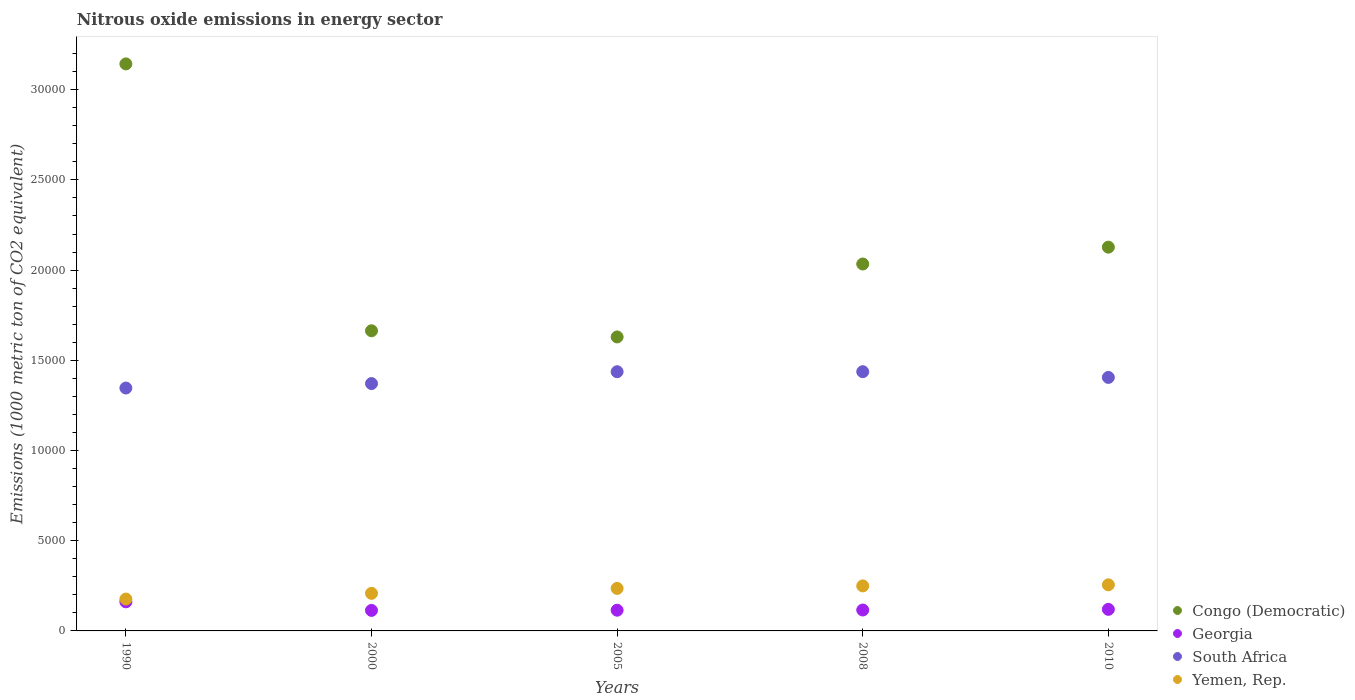How many different coloured dotlines are there?
Give a very brief answer. 4. Is the number of dotlines equal to the number of legend labels?
Ensure brevity in your answer.  Yes. What is the amount of nitrous oxide emitted in Georgia in 2010?
Keep it short and to the point. 1195.6. Across all years, what is the maximum amount of nitrous oxide emitted in Yemen, Rep.?
Offer a very short reply. 2555.7. Across all years, what is the minimum amount of nitrous oxide emitted in Yemen, Rep.?
Your answer should be compact. 1766.7. What is the total amount of nitrous oxide emitted in Yemen, Rep. in the graph?
Provide a short and direct response. 1.13e+04. What is the difference between the amount of nitrous oxide emitted in Congo (Democratic) in 1990 and that in 2000?
Provide a succinct answer. 1.48e+04. What is the difference between the amount of nitrous oxide emitted in South Africa in 2005 and the amount of nitrous oxide emitted in Congo (Democratic) in 2008?
Your answer should be very brief. -5970.6. What is the average amount of nitrous oxide emitted in Yemen, Rep. per year?
Provide a short and direct response. 2251.4. In the year 2008, what is the difference between the amount of nitrous oxide emitted in South Africa and amount of nitrous oxide emitted in Georgia?
Make the answer very short. 1.32e+04. What is the ratio of the amount of nitrous oxide emitted in Georgia in 2008 to that in 2010?
Provide a short and direct response. 0.97. What is the difference between the highest and the second highest amount of nitrous oxide emitted in Yemen, Rep.?
Offer a very short reply. 60. What is the difference between the highest and the lowest amount of nitrous oxide emitted in South Africa?
Offer a terse response. 905.7. In how many years, is the amount of nitrous oxide emitted in Georgia greater than the average amount of nitrous oxide emitted in Georgia taken over all years?
Your response must be concise. 1. Is it the case that in every year, the sum of the amount of nitrous oxide emitted in Congo (Democratic) and amount of nitrous oxide emitted in Yemen, Rep.  is greater than the sum of amount of nitrous oxide emitted in South Africa and amount of nitrous oxide emitted in Georgia?
Ensure brevity in your answer.  Yes. Is it the case that in every year, the sum of the amount of nitrous oxide emitted in Congo (Democratic) and amount of nitrous oxide emitted in Yemen, Rep.  is greater than the amount of nitrous oxide emitted in Georgia?
Provide a succinct answer. Yes. Is the amount of nitrous oxide emitted in South Africa strictly greater than the amount of nitrous oxide emitted in Yemen, Rep. over the years?
Keep it short and to the point. Yes. Is the amount of nitrous oxide emitted in Georgia strictly less than the amount of nitrous oxide emitted in Yemen, Rep. over the years?
Give a very brief answer. Yes. How many years are there in the graph?
Give a very brief answer. 5. What is the difference between two consecutive major ticks on the Y-axis?
Make the answer very short. 5000. Does the graph contain any zero values?
Your answer should be compact. No. What is the title of the graph?
Provide a short and direct response. Nitrous oxide emissions in energy sector. What is the label or title of the Y-axis?
Give a very brief answer. Emissions (1000 metric ton of CO2 equivalent). What is the Emissions (1000 metric ton of CO2 equivalent) in Congo (Democratic) in 1990?
Your answer should be very brief. 3.14e+04. What is the Emissions (1000 metric ton of CO2 equivalent) of Georgia in 1990?
Offer a very short reply. 1613.4. What is the Emissions (1000 metric ton of CO2 equivalent) of South Africa in 1990?
Offer a terse response. 1.35e+04. What is the Emissions (1000 metric ton of CO2 equivalent) in Yemen, Rep. in 1990?
Your response must be concise. 1766.7. What is the Emissions (1000 metric ton of CO2 equivalent) of Congo (Democratic) in 2000?
Provide a succinct answer. 1.66e+04. What is the Emissions (1000 metric ton of CO2 equivalent) in Georgia in 2000?
Provide a short and direct response. 1137.6. What is the Emissions (1000 metric ton of CO2 equivalent) in South Africa in 2000?
Keep it short and to the point. 1.37e+04. What is the Emissions (1000 metric ton of CO2 equivalent) in Yemen, Rep. in 2000?
Keep it short and to the point. 2082.9. What is the Emissions (1000 metric ton of CO2 equivalent) of Congo (Democratic) in 2005?
Your answer should be compact. 1.63e+04. What is the Emissions (1000 metric ton of CO2 equivalent) in Georgia in 2005?
Keep it short and to the point. 1148.6. What is the Emissions (1000 metric ton of CO2 equivalent) in South Africa in 2005?
Offer a terse response. 1.44e+04. What is the Emissions (1000 metric ton of CO2 equivalent) in Yemen, Rep. in 2005?
Give a very brief answer. 2356. What is the Emissions (1000 metric ton of CO2 equivalent) of Congo (Democratic) in 2008?
Give a very brief answer. 2.03e+04. What is the Emissions (1000 metric ton of CO2 equivalent) in Georgia in 2008?
Offer a terse response. 1158.8. What is the Emissions (1000 metric ton of CO2 equivalent) of South Africa in 2008?
Your answer should be very brief. 1.44e+04. What is the Emissions (1000 metric ton of CO2 equivalent) of Yemen, Rep. in 2008?
Your answer should be very brief. 2495.7. What is the Emissions (1000 metric ton of CO2 equivalent) of Congo (Democratic) in 2010?
Your answer should be very brief. 2.13e+04. What is the Emissions (1000 metric ton of CO2 equivalent) of Georgia in 2010?
Provide a short and direct response. 1195.6. What is the Emissions (1000 metric ton of CO2 equivalent) in South Africa in 2010?
Your answer should be very brief. 1.41e+04. What is the Emissions (1000 metric ton of CO2 equivalent) of Yemen, Rep. in 2010?
Offer a terse response. 2555.7. Across all years, what is the maximum Emissions (1000 metric ton of CO2 equivalent) in Congo (Democratic)?
Ensure brevity in your answer.  3.14e+04. Across all years, what is the maximum Emissions (1000 metric ton of CO2 equivalent) of Georgia?
Offer a very short reply. 1613.4. Across all years, what is the maximum Emissions (1000 metric ton of CO2 equivalent) in South Africa?
Ensure brevity in your answer.  1.44e+04. Across all years, what is the maximum Emissions (1000 metric ton of CO2 equivalent) of Yemen, Rep.?
Your response must be concise. 2555.7. Across all years, what is the minimum Emissions (1000 metric ton of CO2 equivalent) of Congo (Democratic)?
Your answer should be very brief. 1.63e+04. Across all years, what is the minimum Emissions (1000 metric ton of CO2 equivalent) in Georgia?
Your answer should be very brief. 1137.6. Across all years, what is the minimum Emissions (1000 metric ton of CO2 equivalent) in South Africa?
Your answer should be compact. 1.35e+04. Across all years, what is the minimum Emissions (1000 metric ton of CO2 equivalent) in Yemen, Rep.?
Ensure brevity in your answer.  1766.7. What is the total Emissions (1000 metric ton of CO2 equivalent) of Congo (Democratic) in the graph?
Provide a succinct answer. 1.06e+05. What is the total Emissions (1000 metric ton of CO2 equivalent) in Georgia in the graph?
Keep it short and to the point. 6254. What is the total Emissions (1000 metric ton of CO2 equivalent) in South Africa in the graph?
Offer a very short reply. 7.00e+04. What is the total Emissions (1000 metric ton of CO2 equivalent) of Yemen, Rep. in the graph?
Give a very brief answer. 1.13e+04. What is the difference between the Emissions (1000 metric ton of CO2 equivalent) in Congo (Democratic) in 1990 and that in 2000?
Ensure brevity in your answer.  1.48e+04. What is the difference between the Emissions (1000 metric ton of CO2 equivalent) in Georgia in 1990 and that in 2000?
Keep it short and to the point. 475.8. What is the difference between the Emissions (1000 metric ton of CO2 equivalent) in South Africa in 1990 and that in 2000?
Offer a very short reply. -246.5. What is the difference between the Emissions (1000 metric ton of CO2 equivalent) of Yemen, Rep. in 1990 and that in 2000?
Your response must be concise. -316.2. What is the difference between the Emissions (1000 metric ton of CO2 equivalent) in Congo (Democratic) in 1990 and that in 2005?
Provide a short and direct response. 1.51e+04. What is the difference between the Emissions (1000 metric ton of CO2 equivalent) of Georgia in 1990 and that in 2005?
Ensure brevity in your answer.  464.8. What is the difference between the Emissions (1000 metric ton of CO2 equivalent) of South Africa in 1990 and that in 2005?
Provide a succinct answer. -903.7. What is the difference between the Emissions (1000 metric ton of CO2 equivalent) in Yemen, Rep. in 1990 and that in 2005?
Ensure brevity in your answer.  -589.3. What is the difference between the Emissions (1000 metric ton of CO2 equivalent) in Congo (Democratic) in 1990 and that in 2008?
Keep it short and to the point. 1.11e+04. What is the difference between the Emissions (1000 metric ton of CO2 equivalent) in Georgia in 1990 and that in 2008?
Your answer should be compact. 454.6. What is the difference between the Emissions (1000 metric ton of CO2 equivalent) of South Africa in 1990 and that in 2008?
Your response must be concise. -905.7. What is the difference between the Emissions (1000 metric ton of CO2 equivalent) in Yemen, Rep. in 1990 and that in 2008?
Provide a succinct answer. -729. What is the difference between the Emissions (1000 metric ton of CO2 equivalent) in Congo (Democratic) in 1990 and that in 2010?
Your answer should be very brief. 1.02e+04. What is the difference between the Emissions (1000 metric ton of CO2 equivalent) in Georgia in 1990 and that in 2010?
Your response must be concise. 417.8. What is the difference between the Emissions (1000 metric ton of CO2 equivalent) in South Africa in 1990 and that in 2010?
Provide a short and direct response. -588.2. What is the difference between the Emissions (1000 metric ton of CO2 equivalent) of Yemen, Rep. in 1990 and that in 2010?
Ensure brevity in your answer.  -789. What is the difference between the Emissions (1000 metric ton of CO2 equivalent) in Congo (Democratic) in 2000 and that in 2005?
Offer a terse response. 342.2. What is the difference between the Emissions (1000 metric ton of CO2 equivalent) in Georgia in 2000 and that in 2005?
Your answer should be compact. -11. What is the difference between the Emissions (1000 metric ton of CO2 equivalent) of South Africa in 2000 and that in 2005?
Ensure brevity in your answer.  -657.2. What is the difference between the Emissions (1000 metric ton of CO2 equivalent) of Yemen, Rep. in 2000 and that in 2005?
Give a very brief answer. -273.1. What is the difference between the Emissions (1000 metric ton of CO2 equivalent) in Congo (Democratic) in 2000 and that in 2008?
Give a very brief answer. -3700.5. What is the difference between the Emissions (1000 metric ton of CO2 equivalent) in Georgia in 2000 and that in 2008?
Offer a terse response. -21.2. What is the difference between the Emissions (1000 metric ton of CO2 equivalent) of South Africa in 2000 and that in 2008?
Your answer should be very brief. -659.2. What is the difference between the Emissions (1000 metric ton of CO2 equivalent) in Yemen, Rep. in 2000 and that in 2008?
Your response must be concise. -412.8. What is the difference between the Emissions (1000 metric ton of CO2 equivalent) in Congo (Democratic) in 2000 and that in 2010?
Your answer should be compact. -4634.4. What is the difference between the Emissions (1000 metric ton of CO2 equivalent) in Georgia in 2000 and that in 2010?
Make the answer very short. -58. What is the difference between the Emissions (1000 metric ton of CO2 equivalent) of South Africa in 2000 and that in 2010?
Keep it short and to the point. -341.7. What is the difference between the Emissions (1000 metric ton of CO2 equivalent) in Yemen, Rep. in 2000 and that in 2010?
Offer a very short reply. -472.8. What is the difference between the Emissions (1000 metric ton of CO2 equivalent) of Congo (Democratic) in 2005 and that in 2008?
Make the answer very short. -4042.7. What is the difference between the Emissions (1000 metric ton of CO2 equivalent) in South Africa in 2005 and that in 2008?
Provide a succinct answer. -2. What is the difference between the Emissions (1000 metric ton of CO2 equivalent) of Yemen, Rep. in 2005 and that in 2008?
Ensure brevity in your answer.  -139.7. What is the difference between the Emissions (1000 metric ton of CO2 equivalent) of Congo (Democratic) in 2005 and that in 2010?
Your response must be concise. -4976.6. What is the difference between the Emissions (1000 metric ton of CO2 equivalent) of Georgia in 2005 and that in 2010?
Provide a short and direct response. -47. What is the difference between the Emissions (1000 metric ton of CO2 equivalent) in South Africa in 2005 and that in 2010?
Provide a succinct answer. 315.5. What is the difference between the Emissions (1000 metric ton of CO2 equivalent) of Yemen, Rep. in 2005 and that in 2010?
Offer a very short reply. -199.7. What is the difference between the Emissions (1000 metric ton of CO2 equivalent) of Congo (Democratic) in 2008 and that in 2010?
Offer a terse response. -933.9. What is the difference between the Emissions (1000 metric ton of CO2 equivalent) of Georgia in 2008 and that in 2010?
Make the answer very short. -36.8. What is the difference between the Emissions (1000 metric ton of CO2 equivalent) of South Africa in 2008 and that in 2010?
Offer a very short reply. 317.5. What is the difference between the Emissions (1000 metric ton of CO2 equivalent) of Yemen, Rep. in 2008 and that in 2010?
Ensure brevity in your answer.  -60. What is the difference between the Emissions (1000 metric ton of CO2 equivalent) in Congo (Democratic) in 1990 and the Emissions (1000 metric ton of CO2 equivalent) in Georgia in 2000?
Give a very brief answer. 3.03e+04. What is the difference between the Emissions (1000 metric ton of CO2 equivalent) of Congo (Democratic) in 1990 and the Emissions (1000 metric ton of CO2 equivalent) of South Africa in 2000?
Your response must be concise. 1.77e+04. What is the difference between the Emissions (1000 metric ton of CO2 equivalent) of Congo (Democratic) in 1990 and the Emissions (1000 metric ton of CO2 equivalent) of Yemen, Rep. in 2000?
Your answer should be very brief. 2.93e+04. What is the difference between the Emissions (1000 metric ton of CO2 equivalent) in Georgia in 1990 and the Emissions (1000 metric ton of CO2 equivalent) in South Africa in 2000?
Your answer should be compact. -1.21e+04. What is the difference between the Emissions (1000 metric ton of CO2 equivalent) of Georgia in 1990 and the Emissions (1000 metric ton of CO2 equivalent) of Yemen, Rep. in 2000?
Your answer should be compact. -469.5. What is the difference between the Emissions (1000 metric ton of CO2 equivalent) in South Africa in 1990 and the Emissions (1000 metric ton of CO2 equivalent) in Yemen, Rep. in 2000?
Offer a very short reply. 1.14e+04. What is the difference between the Emissions (1000 metric ton of CO2 equivalent) in Congo (Democratic) in 1990 and the Emissions (1000 metric ton of CO2 equivalent) in Georgia in 2005?
Keep it short and to the point. 3.03e+04. What is the difference between the Emissions (1000 metric ton of CO2 equivalent) in Congo (Democratic) in 1990 and the Emissions (1000 metric ton of CO2 equivalent) in South Africa in 2005?
Offer a very short reply. 1.71e+04. What is the difference between the Emissions (1000 metric ton of CO2 equivalent) of Congo (Democratic) in 1990 and the Emissions (1000 metric ton of CO2 equivalent) of Yemen, Rep. in 2005?
Offer a terse response. 2.91e+04. What is the difference between the Emissions (1000 metric ton of CO2 equivalent) of Georgia in 1990 and the Emissions (1000 metric ton of CO2 equivalent) of South Africa in 2005?
Offer a terse response. -1.28e+04. What is the difference between the Emissions (1000 metric ton of CO2 equivalent) of Georgia in 1990 and the Emissions (1000 metric ton of CO2 equivalent) of Yemen, Rep. in 2005?
Offer a terse response. -742.6. What is the difference between the Emissions (1000 metric ton of CO2 equivalent) in South Africa in 1990 and the Emissions (1000 metric ton of CO2 equivalent) in Yemen, Rep. in 2005?
Offer a terse response. 1.11e+04. What is the difference between the Emissions (1000 metric ton of CO2 equivalent) in Congo (Democratic) in 1990 and the Emissions (1000 metric ton of CO2 equivalent) in Georgia in 2008?
Provide a succinct answer. 3.03e+04. What is the difference between the Emissions (1000 metric ton of CO2 equivalent) in Congo (Democratic) in 1990 and the Emissions (1000 metric ton of CO2 equivalent) in South Africa in 2008?
Ensure brevity in your answer.  1.71e+04. What is the difference between the Emissions (1000 metric ton of CO2 equivalent) of Congo (Democratic) in 1990 and the Emissions (1000 metric ton of CO2 equivalent) of Yemen, Rep. in 2008?
Your answer should be very brief. 2.89e+04. What is the difference between the Emissions (1000 metric ton of CO2 equivalent) in Georgia in 1990 and the Emissions (1000 metric ton of CO2 equivalent) in South Africa in 2008?
Provide a succinct answer. -1.28e+04. What is the difference between the Emissions (1000 metric ton of CO2 equivalent) in Georgia in 1990 and the Emissions (1000 metric ton of CO2 equivalent) in Yemen, Rep. in 2008?
Your answer should be very brief. -882.3. What is the difference between the Emissions (1000 metric ton of CO2 equivalent) of South Africa in 1990 and the Emissions (1000 metric ton of CO2 equivalent) of Yemen, Rep. in 2008?
Offer a terse response. 1.10e+04. What is the difference between the Emissions (1000 metric ton of CO2 equivalent) in Congo (Democratic) in 1990 and the Emissions (1000 metric ton of CO2 equivalent) in Georgia in 2010?
Provide a short and direct response. 3.02e+04. What is the difference between the Emissions (1000 metric ton of CO2 equivalent) of Congo (Democratic) in 1990 and the Emissions (1000 metric ton of CO2 equivalent) of South Africa in 2010?
Offer a very short reply. 1.74e+04. What is the difference between the Emissions (1000 metric ton of CO2 equivalent) of Congo (Democratic) in 1990 and the Emissions (1000 metric ton of CO2 equivalent) of Yemen, Rep. in 2010?
Keep it short and to the point. 2.89e+04. What is the difference between the Emissions (1000 metric ton of CO2 equivalent) of Georgia in 1990 and the Emissions (1000 metric ton of CO2 equivalent) of South Africa in 2010?
Provide a short and direct response. -1.24e+04. What is the difference between the Emissions (1000 metric ton of CO2 equivalent) of Georgia in 1990 and the Emissions (1000 metric ton of CO2 equivalent) of Yemen, Rep. in 2010?
Make the answer very short. -942.3. What is the difference between the Emissions (1000 metric ton of CO2 equivalent) of South Africa in 1990 and the Emissions (1000 metric ton of CO2 equivalent) of Yemen, Rep. in 2010?
Provide a succinct answer. 1.09e+04. What is the difference between the Emissions (1000 metric ton of CO2 equivalent) of Congo (Democratic) in 2000 and the Emissions (1000 metric ton of CO2 equivalent) of Georgia in 2005?
Your response must be concise. 1.55e+04. What is the difference between the Emissions (1000 metric ton of CO2 equivalent) of Congo (Democratic) in 2000 and the Emissions (1000 metric ton of CO2 equivalent) of South Africa in 2005?
Your answer should be compact. 2270.1. What is the difference between the Emissions (1000 metric ton of CO2 equivalent) of Congo (Democratic) in 2000 and the Emissions (1000 metric ton of CO2 equivalent) of Yemen, Rep. in 2005?
Ensure brevity in your answer.  1.43e+04. What is the difference between the Emissions (1000 metric ton of CO2 equivalent) of Georgia in 2000 and the Emissions (1000 metric ton of CO2 equivalent) of South Africa in 2005?
Your response must be concise. -1.32e+04. What is the difference between the Emissions (1000 metric ton of CO2 equivalent) in Georgia in 2000 and the Emissions (1000 metric ton of CO2 equivalent) in Yemen, Rep. in 2005?
Your response must be concise. -1218.4. What is the difference between the Emissions (1000 metric ton of CO2 equivalent) of South Africa in 2000 and the Emissions (1000 metric ton of CO2 equivalent) of Yemen, Rep. in 2005?
Offer a very short reply. 1.14e+04. What is the difference between the Emissions (1000 metric ton of CO2 equivalent) in Congo (Democratic) in 2000 and the Emissions (1000 metric ton of CO2 equivalent) in Georgia in 2008?
Keep it short and to the point. 1.55e+04. What is the difference between the Emissions (1000 metric ton of CO2 equivalent) of Congo (Democratic) in 2000 and the Emissions (1000 metric ton of CO2 equivalent) of South Africa in 2008?
Provide a succinct answer. 2268.1. What is the difference between the Emissions (1000 metric ton of CO2 equivalent) in Congo (Democratic) in 2000 and the Emissions (1000 metric ton of CO2 equivalent) in Yemen, Rep. in 2008?
Keep it short and to the point. 1.41e+04. What is the difference between the Emissions (1000 metric ton of CO2 equivalent) in Georgia in 2000 and the Emissions (1000 metric ton of CO2 equivalent) in South Africa in 2008?
Give a very brief answer. -1.32e+04. What is the difference between the Emissions (1000 metric ton of CO2 equivalent) in Georgia in 2000 and the Emissions (1000 metric ton of CO2 equivalent) in Yemen, Rep. in 2008?
Your answer should be very brief. -1358.1. What is the difference between the Emissions (1000 metric ton of CO2 equivalent) of South Africa in 2000 and the Emissions (1000 metric ton of CO2 equivalent) of Yemen, Rep. in 2008?
Your response must be concise. 1.12e+04. What is the difference between the Emissions (1000 metric ton of CO2 equivalent) in Congo (Democratic) in 2000 and the Emissions (1000 metric ton of CO2 equivalent) in Georgia in 2010?
Ensure brevity in your answer.  1.54e+04. What is the difference between the Emissions (1000 metric ton of CO2 equivalent) of Congo (Democratic) in 2000 and the Emissions (1000 metric ton of CO2 equivalent) of South Africa in 2010?
Offer a very short reply. 2585.6. What is the difference between the Emissions (1000 metric ton of CO2 equivalent) of Congo (Democratic) in 2000 and the Emissions (1000 metric ton of CO2 equivalent) of Yemen, Rep. in 2010?
Your answer should be very brief. 1.41e+04. What is the difference between the Emissions (1000 metric ton of CO2 equivalent) of Georgia in 2000 and the Emissions (1000 metric ton of CO2 equivalent) of South Africa in 2010?
Keep it short and to the point. -1.29e+04. What is the difference between the Emissions (1000 metric ton of CO2 equivalent) of Georgia in 2000 and the Emissions (1000 metric ton of CO2 equivalent) of Yemen, Rep. in 2010?
Your response must be concise. -1418.1. What is the difference between the Emissions (1000 metric ton of CO2 equivalent) of South Africa in 2000 and the Emissions (1000 metric ton of CO2 equivalent) of Yemen, Rep. in 2010?
Offer a very short reply. 1.12e+04. What is the difference between the Emissions (1000 metric ton of CO2 equivalent) in Congo (Democratic) in 2005 and the Emissions (1000 metric ton of CO2 equivalent) in Georgia in 2008?
Give a very brief answer. 1.51e+04. What is the difference between the Emissions (1000 metric ton of CO2 equivalent) in Congo (Democratic) in 2005 and the Emissions (1000 metric ton of CO2 equivalent) in South Africa in 2008?
Make the answer very short. 1925.9. What is the difference between the Emissions (1000 metric ton of CO2 equivalent) of Congo (Democratic) in 2005 and the Emissions (1000 metric ton of CO2 equivalent) of Yemen, Rep. in 2008?
Make the answer very short. 1.38e+04. What is the difference between the Emissions (1000 metric ton of CO2 equivalent) in Georgia in 2005 and the Emissions (1000 metric ton of CO2 equivalent) in South Africa in 2008?
Ensure brevity in your answer.  -1.32e+04. What is the difference between the Emissions (1000 metric ton of CO2 equivalent) of Georgia in 2005 and the Emissions (1000 metric ton of CO2 equivalent) of Yemen, Rep. in 2008?
Offer a very short reply. -1347.1. What is the difference between the Emissions (1000 metric ton of CO2 equivalent) of South Africa in 2005 and the Emissions (1000 metric ton of CO2 equivalent) of Yemen, Rep. in 2008?
Your answer should be compact. 1.19e+04. What is the difference between the Emissions (1000 metric ton of CO2 equivalent) of Congo (Democratic) in 2005 and the Emissions (1000 metric ton of CO2 equivalent) of Georgia in 2010?
Keep it short and to the point. 1.51e+04. What is the difference between the Emissions (1000 metric ton of CO2 equivalent) of Congo (Democratic) in 2005 and the Emissions (1000 metric ton of CO2 equivalent) of South Africa in 2010?
Ensure brevity in your answer.  2243.4. What is the difference between the Emissions (1000 metric ton of CO2 equivalent) in Congo (Democratic) in 2005 and the Emissions (1000 metric ton of CO2 equivalent) in Yemen, Rep. in 2010?
Offer a terse response. 1.37e+04. What is the difference between the Emissions (1000 metric ton of CO2 equivalent) in Georgia in 2005 and the Emissions (1000 metric ton of CO2 equivalent) in South Africa in 2010?
Ensure brevity in your answer.  -1.29e+04. What is the difference between the Emissions (1000 metric ton of CO2 equivalent) of Georgia in 2005 and the Emissions (1000 metric ton of CO2 equivalent) of Yemen, Rep. in 2010?
Provide a short and direct response. -1407.1. What is the difference between the Emissions (1000 metric ton of CO2 equivalent) of South Africa in 2005 and the Emissions (1000 metric ton of CO2 equivalent) of Yemen, Rep. in 2010?
Your response must be concise. 1.18e+04. What is the difference between the Emissions (1000 metric ton of CO2 equivalent) of Congo (Democratic) in 2008 and the Emissions (1000 metric ton of CO2 equivalent) of Georgia in 2010?
Your answer should be compact. 1.91e+04. What is the difference between the Emissions (1000 metric ton of CO2 equivalent) in Congo (Democratic) in 2008 and the Emissions (1000 metric ton of CO2 equivalent) in South Africa in 2010?
Your answer should be compact. 6286.1. What is the difference between the Emissions (1000 metric ton of CO2 equivalent) in Congo (Democratic) in 2008 and the Emissions (1000 metric ton of CO2 equivalent) in Yemen, Rep. in 2010?
Keep it short and to the point. 1.78e+04. What is the difference between the Emissions (1000 metric ton of CO2 equivalent) in Georgia in 2008 and the Emissions (1000 metric ton of CO2 equivalent) in South Africa in 2010?
Give a very brief answer. -1.29e+04. What is the difference between the Emissions (1000 metric ton of CO2 equivalent) of Georgia in 2008 and the Emissions (1000 metric ton of CO2 equivalent) of Yemen, Rep. in 2010?
Your answer should be very brief. -1396.9. What is the difference between the Emissions (1000 metric ton of CO2 equivalent) in South Africa in 2008 and the Emissions (1000 metric ton of CO2 equivalent) in Yemen, Rep. in 2010?
Offer a very short reply. 1.18e+04. What is the average Emissions (1000 metric ton of CO2 equivalent) in Congo (Democratic) per year?
Your response must be concise. 2.12e+04. What is the average Emissions (1000 metric ton of CO2 equivalent) of Georgia per year?
Ensure brevity in your answer.  1250.8. What is the average Emissions (1000 metric ton of CO2 equivalent) in South Africa per year?
Provide a short and direct response. 1.40e+04. What is the average Emissions (1000 metric ton of CO2 equivalent) in Yemen, Rep. per year?
Provide a succinct answer. 2251.4. In the year 1990, what is the difference between the Emissions (1000 metric ton of CO2 equivalent) of Congo (Democratic) and Emissions (1000 metric ton of CO2 equivalent) of Georgia?
Give a very brief answer. 2.98e+04. In the year 1990, what is the difference between the Emissions (1000 metric ton of CO2 equivalent) in Congo (Democratic) and Emissions (1000 metric ton of CO2 equivalent) in South Africa?
Your response must be concise. 1.80e+04. In the year 1990, what is the difference between the Emissions (1000 metric ton of CO2 equivalent) in Congo (Democratic) and Emissions (1000 metric ton of CO2 equivalent) in Yemen, Rep.?
Make the answer very short. 2.97e+04. In the year 1990, what is the difference between the Emissions (1000 metric ton of CO2 equivalent) in Georgia and Emissions (1000 metric ton of CO2 equivalent) in South Africa?
Your answer should be compact. -1.18e+04. In the year 1990, what is the difference between the Emissions (1000 metric ton of CO2 equivalent) of Georgia and Emissions (1000 metric ton of CO2 equivalent) of Yemen, Rep.?
Ensure brevity in your answer.  -153.3. In the year 1990, what is the difference between the Emissions (1000 metric ton of CO2 equivalent) in South Africa and Emissions (1000 metric ton of CO2 equivalent) in Yemen, Rep.?
Your response must be concise. 1.17e+04. In the year 2000, what is the difference between the Emissions (1000 metric ton of CO2 equivalent) in Congo (Democratic) and Emissions (1000 metric ton of CO2 equivalent) in Georgia?
Give a very brief answer. 1.55e+04. In the year 2000, what is the difference between the Emissions (1000 metric ton of CO2 equivalent) in Congo (Democratic) and Emissions (1000 metric ton of CO2 equivalent) in South Africa?
Give a very brief answer. 2927.3. In the year 2000, what is the difference between the Emissions (1000 metric ton of CO2 equivalent) of Congo (Democratic) and Emissions (1000 metric ton of CO2 equivalent) of Yemen, Rep.?
Keep it short and to the point. 1.46e+04. In the year 2000, what is the difference between the Emissions (1000 metric ton of CO2 equivalent) in Georgia and Emissions (1000 metric ton of CO2 equivalent) in South Africa?
Your answer should be very brief. -1.26e+04. In the year 2000, what is the difference between the Emissions (1000 metric ton of CO2 equivalent) of Georgia and Emissions (1000 metric ton of CO2 equivalent) of Yemen, Rep.?
Make the answer very short. -945.3. In the year 2000, what is the difference between the Emissions (1000 metric ton of CO2 equivalent) of South Africa and Emissions (1000 metric ton of CO2 equivalent) of Yemen, Rep.?
Your response must be concise. 1.16e+04. In the year 2005, what is the difference between the Emissions (1000 metric ton of CO2 equivalent) of Congo (Democratic) and Emissions (1000 metric ton of CO2 equivalent) of Georgia?
Provide a succinct answer. 1.51e+04. In the year 2005, what is the difference between the Emissions (1000 metric ton of CO2 equivalent) of Congo (Democratic) and Emissions (1000 metric ton of CO2 equivalent) of South Africa?
Ensure brevity in your answer.  1927.9. In the year 2005, what is the difference between the Emissions (1000 metric ton of CO2 equivalent) in Congo (Democratic) and Emissions (1000 metric ton of CO2 equivalent) in Yemen, Rep.?
Your answer should be compact. 1.39e+04. In the year 2005, what is the difference between the Emissions (1000 metric ton of CO2 equivalent) of Georgia and Emissions (1000 metric ton of CO2 equivalent) of South Africa?
Give a very brief answer. -1.32e+04. In the year 2005, what is the difference between the Emissions (1000 metric ton of CO2 equivalent) in Georgia and Emissions (1000 metric ton of CO2 equivalent) in Yemen, Rep.?
Offer a terse response. -1207.4. In the year 2005, what is the difference between the Emissions (1000 metric ton of CO2 equivalent) of South Africa and Emissions (1000 metric ton of CO2 equivalent) of Yemen, Rep.?
Provide a succinct answer. 1.20e+04. In the year 2008, what is the difference between the Emissions (1000 metric ton of CO2 equivalent) in Congo (Democratic) and Emissions (1000 metric ton of CO2 equivalent) in Georgia?
Make the answer very short. 1.92e+04. In the year 2008, what is the difference between the Emissions (1000 metric ton of CO2 equivalent) in Congo (Democratic) and Emissions (1000 metric ton of CO2 equivalent) in South Africa?
Give a very brief answer. 5968.6. In the year 2008, what is the difference between the Emissions (1000 metric ton of CO2 equivalent) in Congo (Democratic) and Emissions (1000 metric ton of CO2 equivalent) in Yemen, Rep.?
Your response must be concise. 1.78e+04. In the year 2008, what is the difference between the Emissions (1000 metric ton of CO2 equivalent) of Georgia and Emissions (1000 metric ton of CO2 equivalent) of South Africa?
Give a very brief answer. -1.32e+04. In the year 2008, what is the difference between the Emissions (1000 metric ton of CO2 equivalent) of Georgia and Emissions (1000 metric ton of CO2 equivalent) of Yemen, Rep.?
Your answer should be compact. -1336.9. In the year 2008, what is the difference between the Emissions (1000 metric ton of CO2 equivalent) of South Africa and Emissions (1000 metric ton of CO2 equivalent) of Yemen, Rep.?
Ensure brevity in your answer.  1.19e+04. In the year 2010, what is the difference between the Emissions (1000 metric ton of CO2 equivalent) of Congo (Democratic) and Emissions (1000 metric ton of CO2 equivalent) of Georgia?
Your answer should be compact. 2.01e+04. In the year 2010, what is the difference between the Emissions (1000 metric ton of CO2 equivalent) of Congo (Democratic) and Emissions (1000 metric ton of CO2 equivalent) of South Africa?
Make the answer very short. 7220. In the year 2010, what is the difference between the Emissions (1000 metric ton of CO2 equivalent) in Congo (Democratic) and Emissions (1000 metric ton of CO2 equivalent) in Yemen, Rep.?
Ensure brevity in your answer.  1.87e+04. In the year 2010, what is the difference between the Emissions (1000 metric ton of CO2 equivalent) of Georgia and Emissions (1000 metric ton of CO2 equivalent) of South Africa?
Provide a succinct answer. -1.29e+04. In the year 2010, what is the difference between the Emissions (1000 metric ton of CO2 equivalent) of Georgia and Emissions (1000 metric ton of CO2 equivalent) of Yemen, Rep.?
Give a very brief answer. -1360.1. In the year 2010, what is the difference between the Emissions (1000 metric ton of CO2 equivalent) in South Africa and Emissions (1000 metric ton of CO2 equivalent) in Yemen, Rep.?
Provide a short and direct response. 1.15e+04. What is the ratio of the Emissions (1000 metric ton of CO2 equivalent) of Congo (Democratic) in 1990 to that in 2000?
Ensure brevity in your answer.  1.89. What is the ratio of the Emissions (1000 metric ton of CO2 equivalent) in Georgia in 1990 to that in 2000?
Offer a very short reply. 1.42. What is the ratio of the Emissions (1000 metric ton of CO2 equivalent) in South Africa in 1990 to that in 2000?
Your answer should be compact. 0.98. What is the ratio of the Emissions (1000 metric ton of CO2 equivalent) in Yemen, Rep. in 1990 to that in 2000?
Your answer should be very brief. 0.85. What is the ratio of the Emissions (1000 metric ton of CO2 equivalent) of Congo (Democratic) in 1990 to that in 2005?
Offer a terse response. 1.93. What is the ratio of the Emissions (1000 metric ton of CO2 equivalent) of Georgia in 1990 to that in 2005?
Your answer should be very brief. 1.4. What is the ratio of the Emissions (1000 metric ton of CO2 equivalent) of South Africa in 1990 to that in 2005?
Provide a short and direct response. 0.94. What is the ratio of the Emissions (1000 metric ton of CO2 equivalent) of Yemen, Rep. in 1990 to that in 2005?
Your response must be concise. 0.75. What is the ratio of the Emissions (1000 metric ton of CO2 equivalent) of Congo (Democratic) in 1990 to that in 2008?
Provide a short and direct response. 1.55. What is the ratio of the Emissions (1000 metric ton of CO2 equivalent) in Georgia in 1990 to that in 2008?
Provide a succinct answer. 1.39. What is the ratio of the Emissions (1000 metric ton of CO2 equivalent) of South Africa in 1990 to that in 2008?
Your answer should be compact. 0.94. What is the ratio of the Emissions (1000 metric ton of CO2 equivalent) of Yemen, Rep. in 1990 to that in 2008?
Offer a terse response. 0.71. What is the ratio of the Emissions (1000 metric ton of CO2 equivalent) in Congo (Democratic) in 1990 to that in 2010?
Provide a succinct answer. 1.48. What is the ratio of the Emissions (1000 metric ton of CO2 equivalent) in Georgia in 1990 to that in 2010?
Give a very brief answer. 1.35. What is the ratio of the Emissions (1000 metric ton of CO2 equivalent) in South Africa in 1990 to that in 2010?
Give a very brief answer. 0.96. What is the ratio of the Emissions (1000 metric ton of CO2 equivalent) of Yemen, Rep. in 1990 to that in 2010?
Provide a succinct answer. 0.69. What is the ratio of the Emissions (1000 metric ton of CO2 equivalent) of Georgia in 2000 to that in 2005?
Your answer should be very brief. 0.99. What is the ratio of the Emissions (1000 metric ton of CO2 equivalent) of South Africa in 2000 to that in 2005?
Provide a short and direct response. 0.95. What is the ratio of the Emissions (1000 metric ton of CO2 equivalent) of Yemen, Rep. in 2000 to that in 2005?
Offer a terse response. 0.88. What is the ratio of the Emissions (1000 metric ton of CO2 equivalent) of Congo (Democratic) in 2000 to that in 2008?
Give a very brief answer. 0.82. What is the ratio of the Emissions (1000 metric ton of CO2 equivalent) of Georgia in 2000 to that in 2008?
Offer a very short reply. 0.98. What is the ratio of the Emissions (1000 metric ton of CO2 equivalent) in South Africa in 2000 to that in 2008?
Your answer should be compact. 0.95. What is the ratio of the Emissions (1000 metric ton of CO2 equivalent) of Yemen, Rep. in 2000 to that in 2008?
Ensure brevity in your answer.  0.83. What is the ratio of the Emissions (1000 metric ton of CO2 equivalent) of Congo (Democratic) in 2000 to that in 2010?
Your response must be concise. 0.78. What is the ratio of the Emissions (1000 metric ton of CO2 equivalent) in Georgia in 2000 to that in 2010?
Provide a succinct answer. 0.95. What is the ratio of the Emissions (1000 metric ton of CO2 equivalent) in South Africa in 2000 to that in 2010?
Your response must be concise. 0.98. What is the ratio of the Emissions (1000 metric ton of CO2 equivalent) in Yemen, Rep. in 2000 to that in 2010?
Provide a succinct answer. 0.81. What is the ratio of the Emissions (1000 metric ton of CO2 equivalent) of Congo (Democratic) in 2005 to that in 2008?
Keep it short and to the point. 0.8. What is the ratio of the Emissions (1000 metric ton of CO2 equivalent) of South Africa in 2005 to that in 2008?
Offer a very short reply. 1. What is the ratio of the Emissions (1000 metric ton of CO2 equivalent) in Yemen, Rep. in 2005 to that in 2008?
Your answer should be compact. 0.94. What is the ratio of the Emissions (1000 metric ton of CO2 equivalent) in Congo (Democratic) in 2005 to that in 2010?
Provide a short and direct response. 0.77. What is the ratio of the Emissions (1000 metric ton of CO2 equivalent) of Georgia in 2005 to that in 2010?
Keep it short and to the point. 0.96. What is the ratio of the Emissions (1000 metric ton of CO2 equivalent) in South Africa in 2005 to that in 2010?
Your answer should be compact. 1.02. What is the ratio of the Emissions (1000 metric ton of CO2 equivalent) of Yemen, Rep. in 2005 to that in 2010?
Your answer should be compact. 0.92. What is the ratio of the Emissions (1000 metric ton of CO2 equivalent) in Congo (Democratic) in 2008 to that in 2010?
Make the answer very short. 0.96. What is the ratio of the Emissions (1000 metric ton of CO2 equivalent) of Georgia in 2008 to that in 2010?
Offer a terse response. 0.97. What is the ratio of the Emissions (1000 metric ton of CO2 equivalent) of South Africa in 2008 to that in 2010?
Provide a succinct answer. 1.02. What is the ratio of the Emissions (1000 metric ton of CO2 equivalent) in Yemen, Rep. in 2008 to that in 2010?
Make the answer very short. 0.98. What is the difference between the highest and the second highest Emissions (1000 metric ton of CO2 equivalent) of Congo (Democratic)?
Make the answer very short. 1.02e+04. What is the difference between the highest and the second highest Emissions (1000 metric ton of CO2 equivalent) in Georgia?
Keep it short and to the point. 417.8. What is the difference between the highest and the second highest Emissions (1000 metric ton of CO2 equivalent) of South Africa?
Your answer should be very brief. 2. What is the difference between the highest and the lowest Emissions (1000 metric ton of CO2 equivalent) in Congo (Democratic)?
Offer a terse response. 1.51e+04. What is the difference between the highest and the lowest Emissions (1000 metric ton of CO2 equivalent) of Georgia?
Provide a succinct answer. 475.8. What is the difference between the highest and the lowest Emissions (1000 metric ton of CO2 equivalent) of South Africa?
Make the answer very short. 905.7. What is the difference between the highest and the lowest Emissions (1000 metric ton of CO2 equivalent) of Yemen, Rep.?
Keep it short and to the point. 789. 